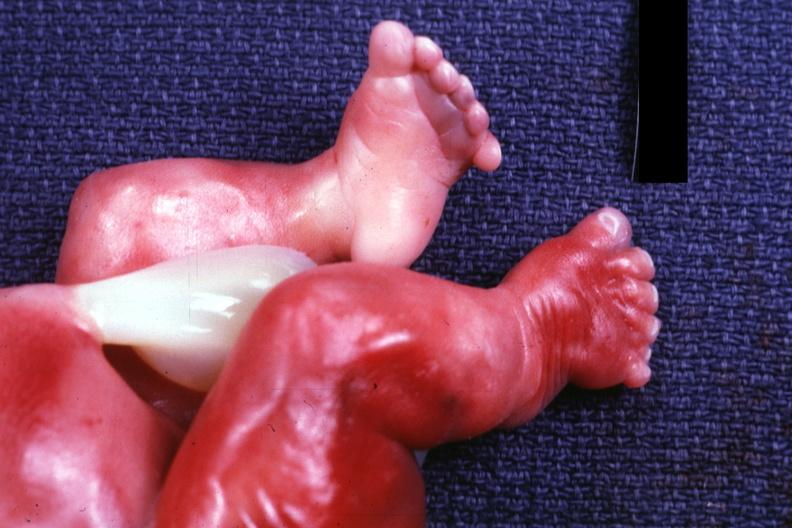what does this image show?
Answer the question using a single word or phrase. Newborn with renal polycystic disease legs are too short 